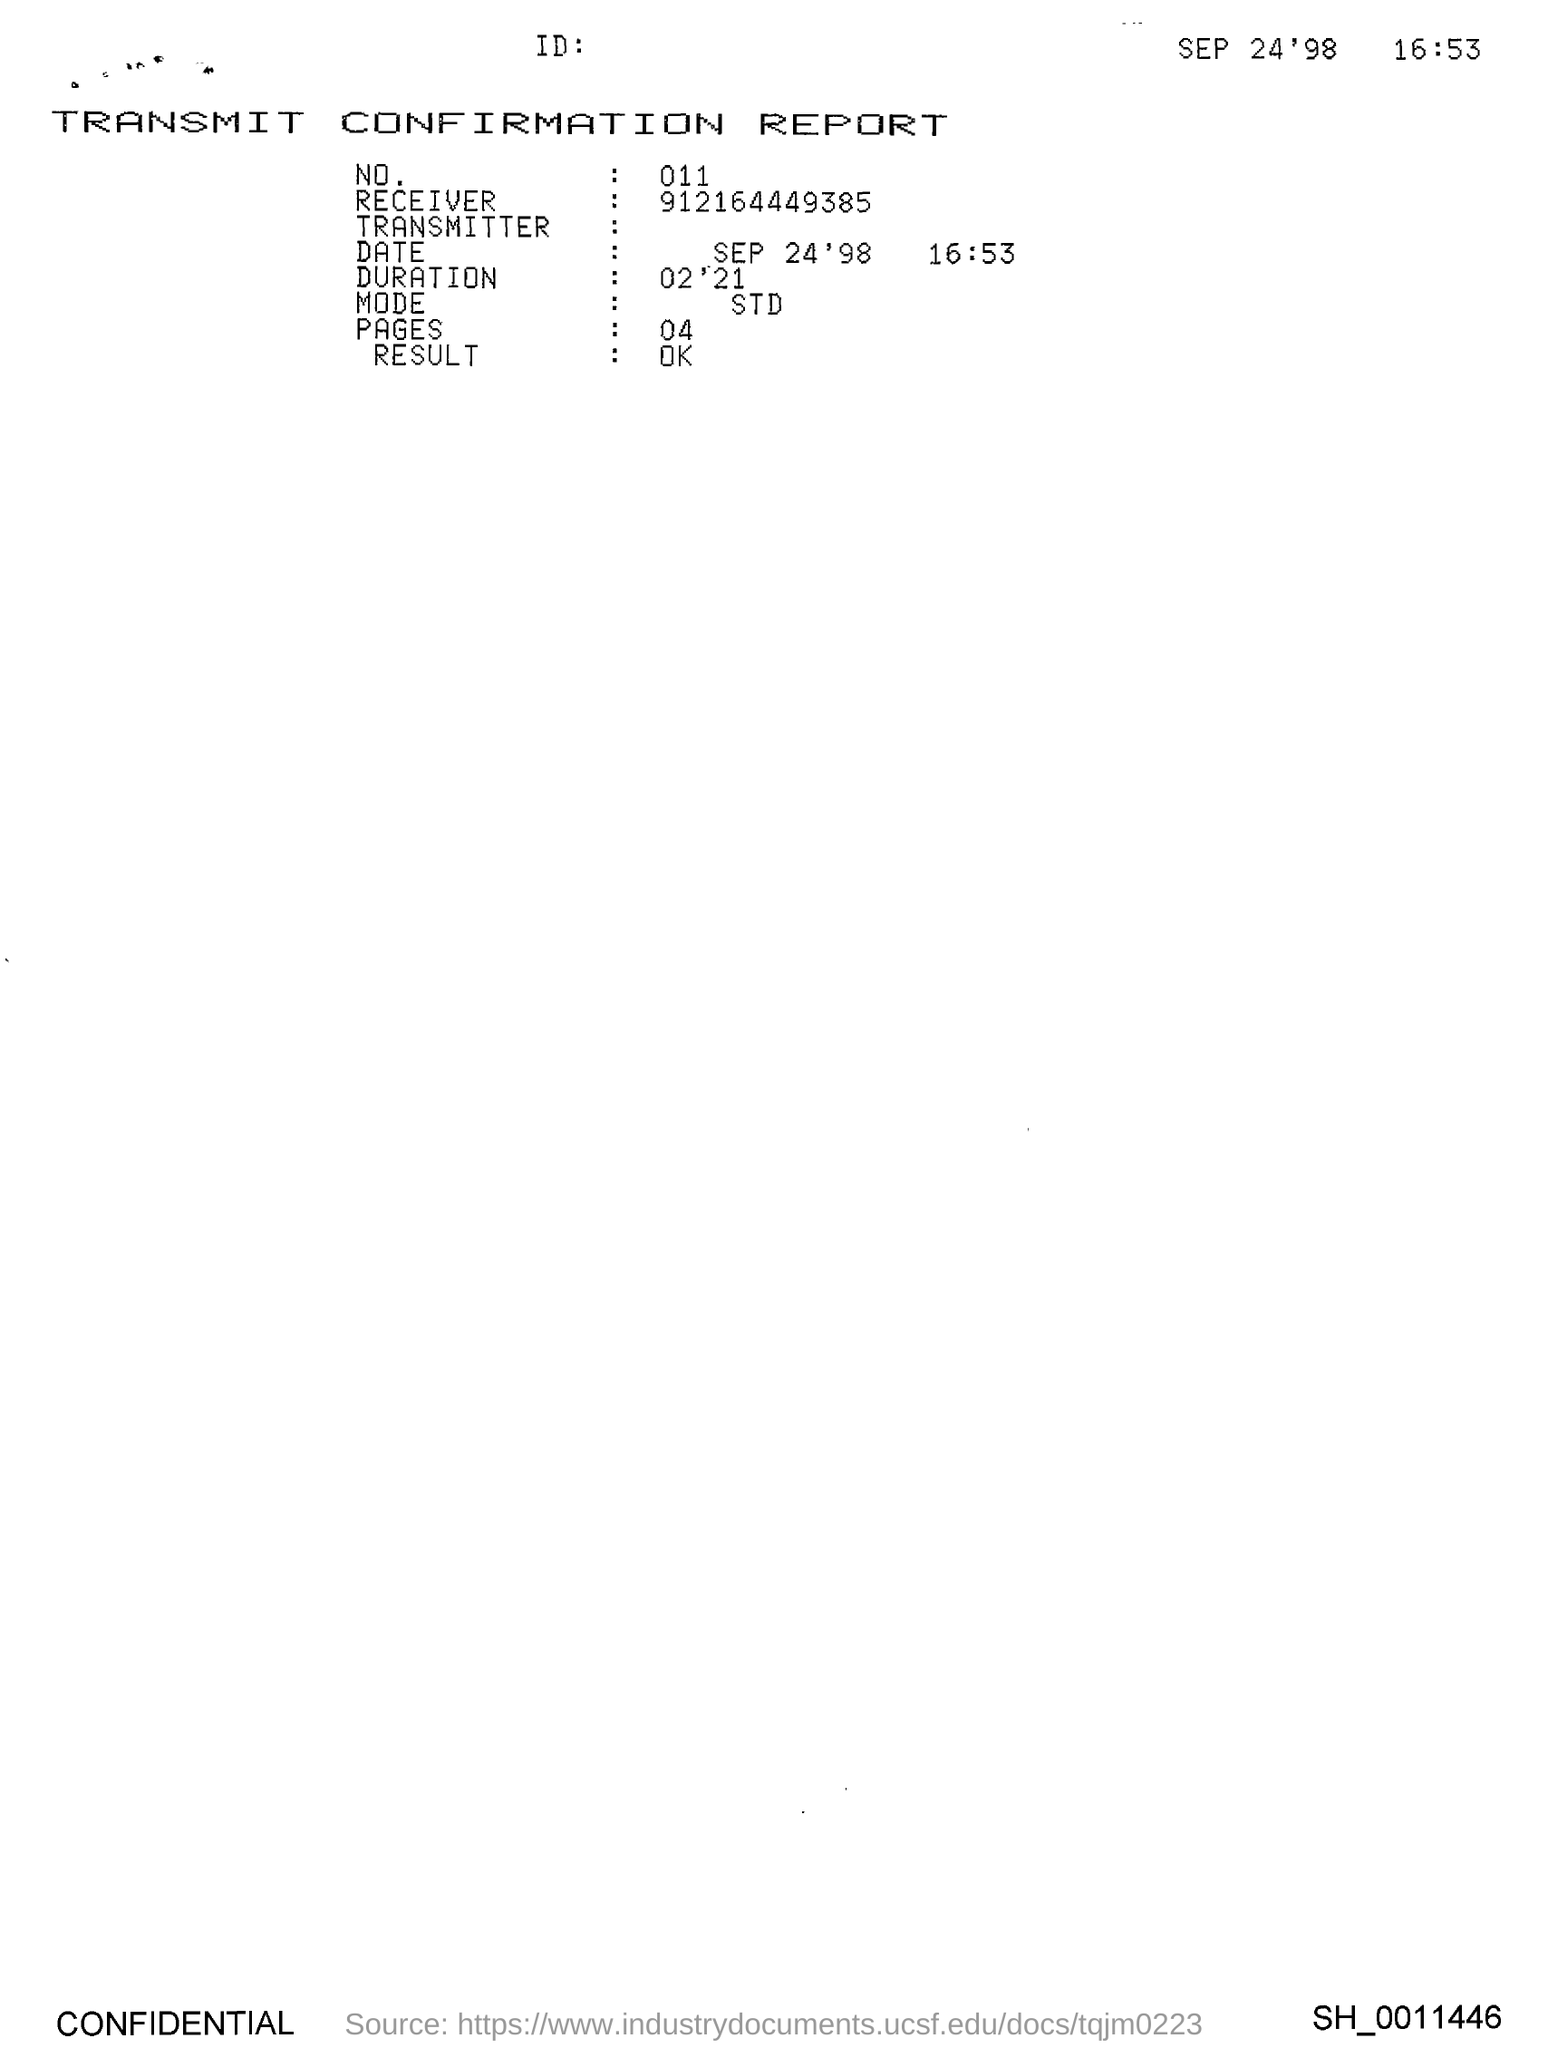Mention a couple of crucial points in this snapshot. The Receiver is a telephone number consisting of nine digits, preceded by the country code of India and followed by a string of numbers. The Receiver is not a valid telephone number as it is not issued by any telecom operator in India. The number is 011... The pages are numbered from 04. The mode is a measure of central tendency in statistics that is calculated by finding the value that appears most frequently in a data set. It is also known as the "most frequent value." Standard deviation is a measure of the spread or dispersion of a data set, which is calculated by finding the difference between each data point and the mean. It is a measure of how much the data points deviate from the mean. The document's title is "Transmit Confirmation Report. 